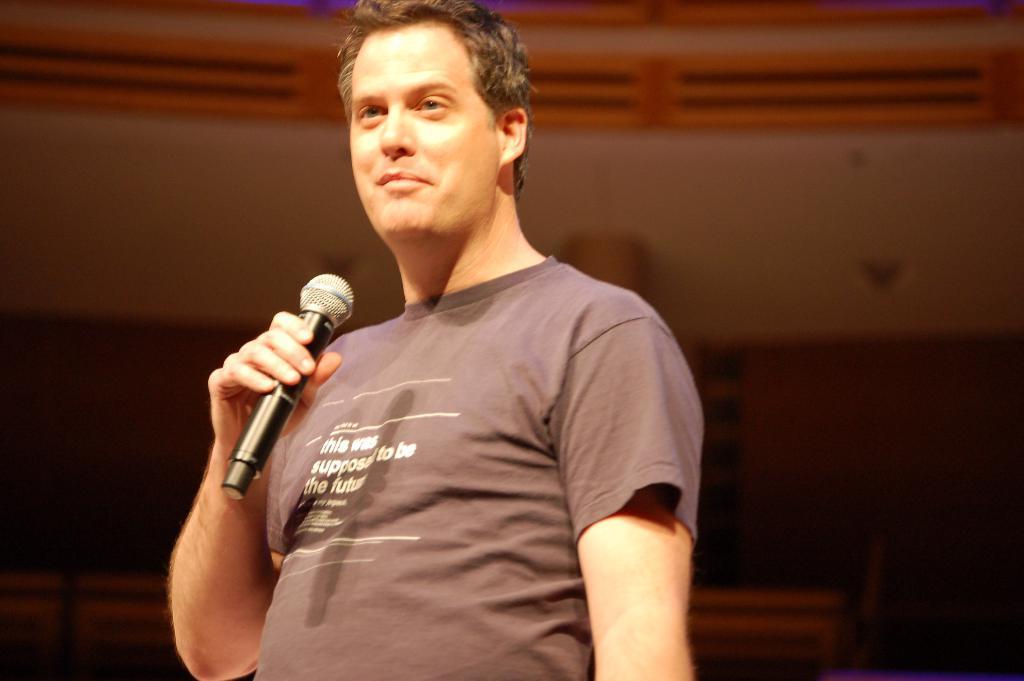In one or two sentences, can you explain what this image depicts? In this image, In the middle there is a man standing and he is holding a microphone which is in black color, In the background there is a white color wall and there are some yellow color grills. 